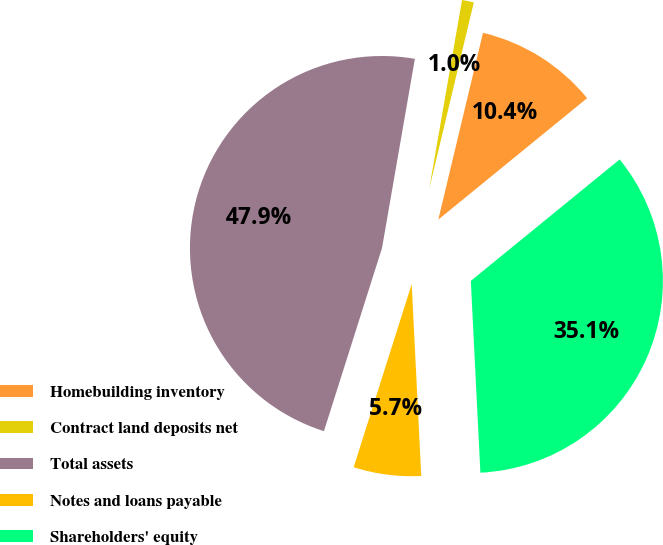Convert chart to OTSL. <chart><loc_0><loc_0><loc_500><loc_500><pie_chart><fcel>Homebuilding inventory<fcel>Contract land deposits net<fcel>Total assets<fcel>Notes and loans payable<fcel>Shareholders' equity<nl><fcel>10.37%<fcel>1.0%<fcel>47.85%<fcel>5.68%<fcel>35.1%<nl></chart> 